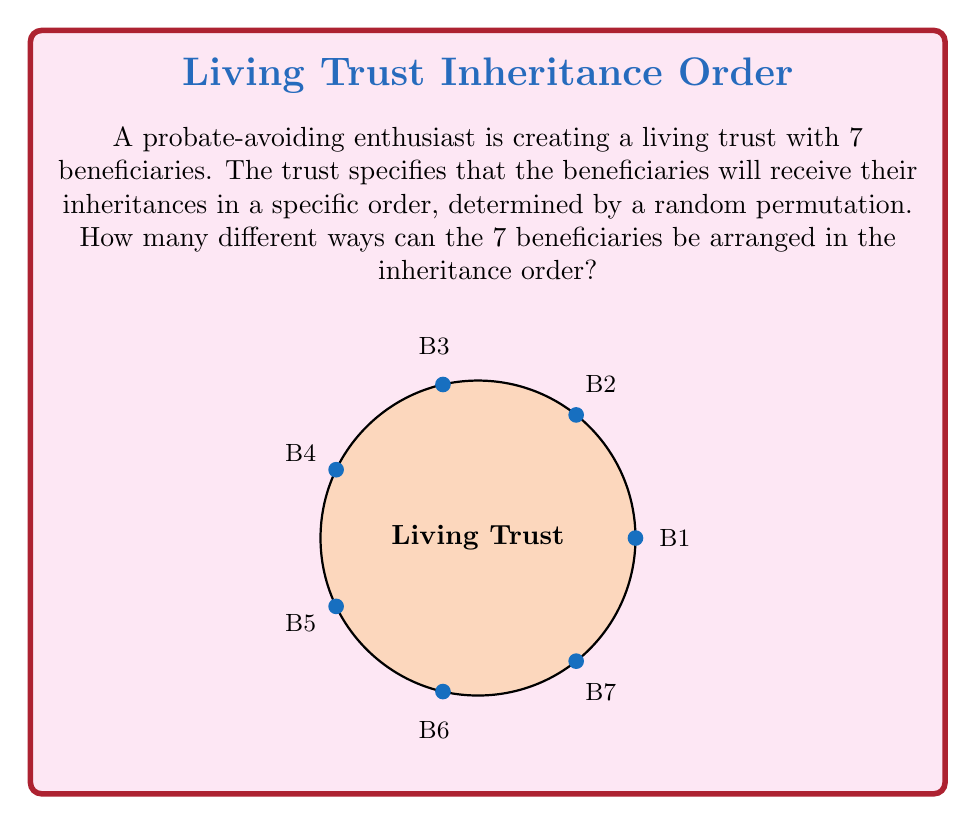Teach me how to tackle this problem. To solve this problem, we need to determine the number of permutations of 7 distinct objects (beneficiaries). In abstract algebra, this is equivalent to finding the order of the symmetric group $S_7$.

1) The number of permutations of n distinct objects is given by n!, where n is the number of objects.

2) In this case, we have 7 beneficiaries, so n = 7.

3) Therefore, the number of permutations is:

   $$7! = 7 \times 6 \times 5 \times 4 \times 3 \times 2 \times 1$$

4) Let's calculate this:
   $$7! = 7 \times 6 \times 5 \times 4 \times 3 \times 2 \times 1 = 5040$$

5) This means there are 5040 different ways to arrange the 7 beneficiaries in the inheritance order.

In terms of group theory, this result represents the order of the symmetric group $S_7$, which is the group of all permutations on a set of 7 elements. Each permutation corresponds to a unique arrangement of the beneficiaries in the inheritance order.
Answer: 5040 